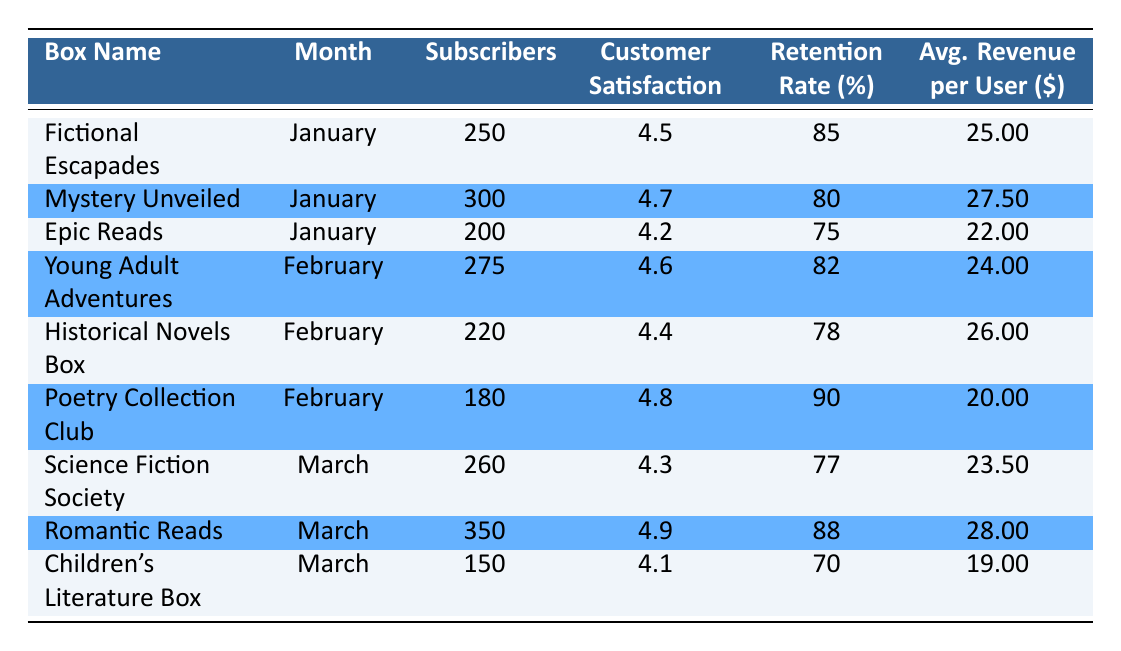What is the customer satisfaction score for "Romantic Reads"? The customer satisfaction score is listed directly in the table under the "Customer Satisfaction" column for the "Romantic Reads" box in March. It indicates a score of 4.9.
Answer: 4.9 Which subscription box had the highest retention rate in February? To find the highest retention rate in February, we compare the retention rates for each box in that month: 82 for "Young Adult Adventures," 78 for "Historical Novels Box," and 90 for "Poetry Collection Club." The highest is 90 from "Poetry Collection Club."
Answer: Poetry Collection Club What is the total number of subscribers for all boxes in January? For January, the number of subscribers for each box is 250 (Fictional Escapades) + 300 (Mystery Unveiled) + 200 (Epic Reads). Adding them gives: 250 + 300 + 200 = 750.
Answer: 750 Is the average revenue per user for "Epic Reads" more than the average for "Fictional Escapades"? The average revenue per user for "Epic Reads" is 22.00 and for "Fictional Escapades" is 25.00. Since 22.00 is less than 25.00, the statement is false.
Answer: No Which box had the lowest customer satisfaction score in March? In March, the customer satisfaction scores are 4.3 (Science Fiction Society), 4.9 (Romantic Reads), and 4.1 (Children's Literature Box). The lowest score is 4.1 from "Children's Literature Box."
Answer: Children's Literature Box What is the average customer satisfaction score across all boxes for January? The scores for January are 4.5 (Fictional Escapades), 4.7 (Mystery Unveiled), and 4.2 (Epic Reads). Adding these: 4.5 + 4.7 + 4.2 = 13.4. Dividing by the 3 entries gives: 13.4 / 3 = 4.47.
Answer: 4.47 Does "Science Fiction Society" have more subscribers than "Children's Literature Box"? Comparing both boxes, "Science Fiction Society" has 260 subscribers, while "Children's Literature Box" has 150. Since 260 is greater than 150, the answer is yes.
Answer: Yes What is the difference in average revenue per user between "Romantic Reads" and "Poetry Collection Club"? The average revenue per user for "Romantic Reads" is 28.00 and for "Poetry Collection Club" is 20.00. The difference is 28.00 - 20.00 = 8.00.
Answer: 8.00 Which month had the highest number of total subscribers across all boxes? We compare the total subscribers for each month: January (750), February (675), and March (760). The highest total is 760 from March.
Answer: March 